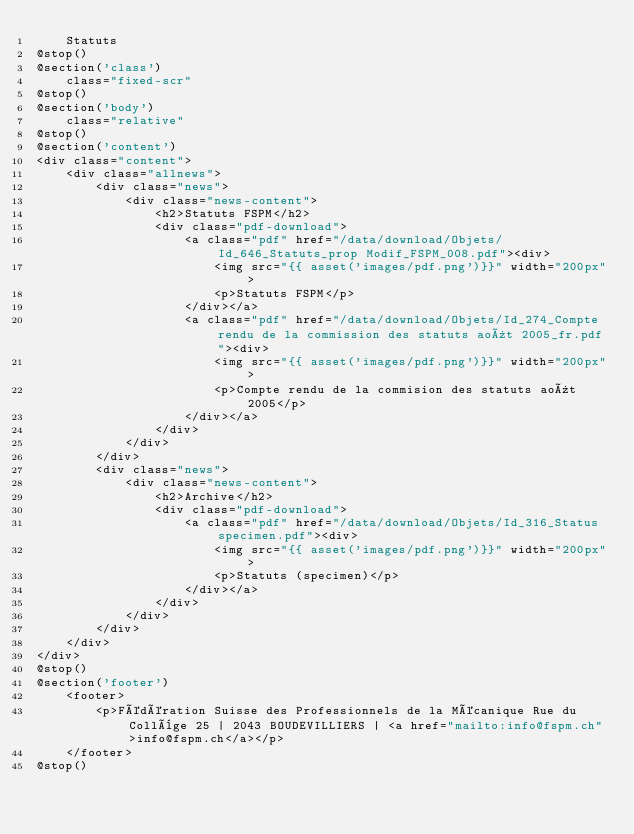Convert code to text. <code><loc_0><loc_0><loc_500><loc_500><_PHP_>    Statuts
@stop()
@section('class')
    class="fixed-scr"
@stop() 
@section('body')
    class="relative"
@stop()   
@section('content')
<div class="content">
    <div class="allnews">
        <div class="news">
            <div class="news-content">
                <h2>Statuts FSPM</h2>
                <div class="pdf-download">
                    <a class="pdf" href="/data/download/Objets/Id_646_Statuts_prop Modif_FSPM_008.pdf"><div>
                        <img src="{{ asset('images/pdf.png')}}" width="200px">
                        <p>Statuts FSPM</p>
                    </div></a>
                    <a class="pdf" href="/data/download/Objets/Id_274_Compte rendu de la commission des statuts août 2005_fr.pdf"><div>
                        <img src="{{ asset('images/pdf.png')}}" width="200px">
                        <p>Compte rendu de la commision des statuts août 2005</p>
                    </div></a>
                </div>
            </div>
        </div>
        <div class="news">
            <div class="news-content">
                <h2>Archive</h2>
                <div class="pdf-download">
                    <a class="pdf" href="/data/download/Objets/Id_316_Status specimen.pdf"><div>
                        <img src="{{ asset('images/pdf.png')}}" width="200px">
                        <p>Statuts (specimen)</p>
                    </div></a>
                </div>
            </div>
        </div>
    </div>
</div>
@stop()
@section('footer')
    <footer>
        <p>Fédération Suisse des Professionnels de la Mécanique Rue du Collège 25 | 2043 BOUDEVILLIERS | <a href="mailto:info@fspm.ch">info@fspm.ch</a></p>
    </footer>
@stop()</code> 